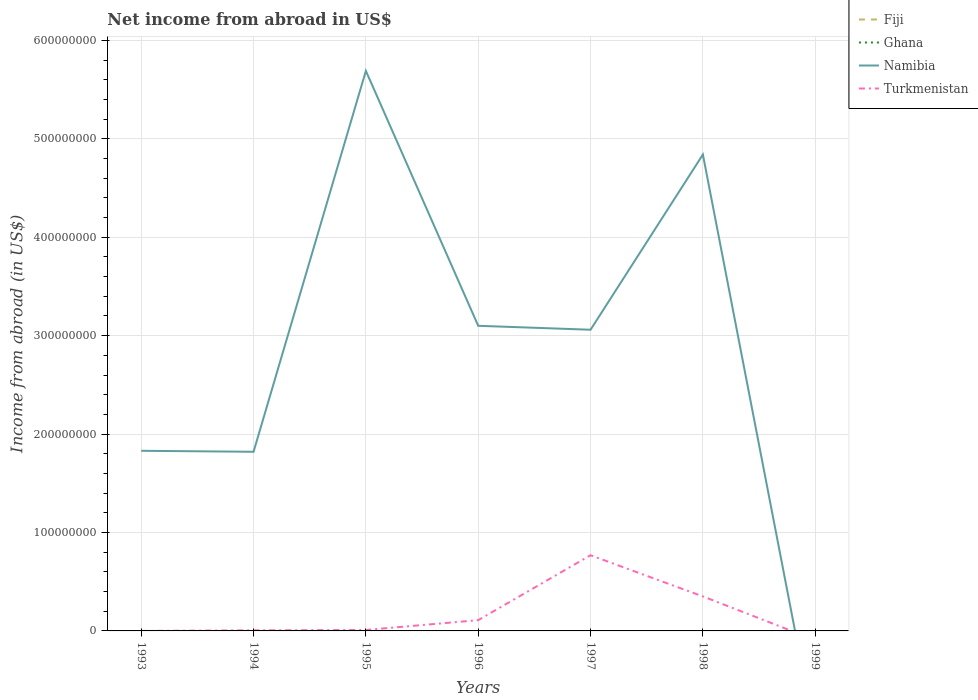How many different coloured lines are there?
Offer a terse response. 2. Does the line corresponding to Turkmenistan intersect with the line corresponding to Ghana?
Give a very brief answer. No. Is the number of lines equal to the number of legend labels?
Provide a short and direct response. No. Across all years, what is the maximum net income from abroad in Turkmenistan?
Keep it short and to the point. 0. What is the total net income from abroad in Turkmenistan in the graph?
Offer a terse response. -2.41e+07. What is the difference between the highest and the second highest net income from abroad in Turkmenistan?
Your response must be concise. 7.69e+07. Is the net income from abroad in Ghana strictly greater than the net income from abroad in Namibia over the years?
Make the answer very short. No. How many lines are there?
Your answer should be compact. 2. What is the difference between two consecutive major ticks on the Y-axis?
Your answer should be very brief. 1.00e+08. Does the graph contain any zero values?
Provide a succinct answer. Yes. Does the graph contain grids?
Ensure brevity in your answer.  Yes. Where does the legend appear in the graph?
Give a very brief answer. Top right. How many legend labels are there?
Make the answer very short. 4. What is the title of the graph?
Give a very brief answer. Net income from abroad in US$. Does "Lao PDR" appear as one of the legend labels in the graph?
Offer a very short reply. No. What is the label or title of the Y-axis?
Your answer should be very brief. Income from abroad (in US$). What is the Income from abroad (in US$) in Fiji in 1993?
Offer a terse response. 0. What is the Income from abroad (in US$) of Ghana in 1993?
Provide a short and direct response. 0. What is the Income from abroad (in US$) of Namibia in 1993?
Your response must be concise. 1.83e+08. What is the Income from abroad (in US$) in Turkmenistan in 1993?
Provide a succinct answer. 1.42e+04. What is the Income from abroad (in US$) of Namibia in 1994?
Ensure brevity in your answer.  1.82e+08. What is the Income from abroad (in US$) in Turkmenistan in 1994?
Make the answer very short. 6.22e+05. What is the Income from abroad (in US$) in Fiji in 1995?
Make the answer very short. 0. What is the Income from abroad (in US$) of Namibia in 1995?
Ensure brevity in your answer.  5.69e+08. What is the Income from abroad (in US$) in Turkmenistan in 1995?
Make the answer very short. 9.67e+05. What is the Income from abroad (in US$) of Ghana in 1996?
Give a very brief answer. 0. What is the Income from abroad (in US$) of Namibia in 1996?
Your answer should be very brief. 3.10e+08. What is the Income from abroad (in US$) of Turkmenistan in 1996?
Provide a succinct answer. 1.09e+07. What is the Income from abroad (in US$) in Fiji in 1997?
Provide a short and direct response. 0. What is the Income from abroad (in US$) of Namibia in 1997?
Provide a succinct answer. 3.06e+08. What is the Income from abroad (in US$) in Turkmenistan in 1997?
Your response must be concise. 7.69e+07. What is the Income from abroad (in US$) in Namibia in 1998?
Your response must be concise. 4.84e+08. What is the Income from abroad (in US$) of Turkmenistan in 1998?
Provide a succinct answer. 3.51e+07. What is the Income from abroad (in US$) of Fiji in 1999?
Make the answer very short. 0. Across all years, what is the maximum Income from abroad (in US$) in Namibia?
Your answer should be compact. 5.69e+08. Across all years, what is the maximum Income from abroad (in US$) of Turkmenistan?
Provide a succinct answer. 7.69e+07. Across all years, what is the minimum Income from abroad (in US$) in Namibia?
Make the answer very short. 0. What is the total Income from abroad (in US$) in Fiji in the graph?
Provide a succinct answer. 0. What is the total Income from abroad (in US$) in Ghana in the graph?
Offer a very short reply. 0. What is the total Income from abroad (in US$) in Namibia in the graph?
Your answer should be very brief. 2.03e+09. What is the total Income from abroad (in US$) in Turkmenistan in the graph?
Keep it short and to the point. 1.25e+08. What is the difference between the Income from abroad (in US$) of Turkmenistan in 1993 and that in 1994?
Your answer should be compact. -6.08e+05. What is the difference between the Income from abroad (in US$) of Namibia in 1993 and that in 1995?
Offer a terse response. -3.86e+08. What is the difference between the Income from abroad (in US$) of Turkmenistan in 1993 and that in 1995?
Offer a very short reply. -9.52e+05. What is the difference between the Income from abroad (in US$) in Namibia in 1993 and that in 1996?
Give a very brief answer. -1.27e+08. What is the difference between the Income from abroad (in US$) in Turkmenistan in 1993 and that in 1996?
Your answer should be compact. -1.09e+07. What is the difference between the Income from abroad (in US$) in Namibia in 1993 and that in 1997?
Ensure brevity in your answer.  -1.23e+08. What is the difference between the Income from abroad (in US$) of Turkmenistan in 1993 and that in 1997?
Make the answer very short. -7.69e+07. What is the difference between the Income from abroad (in US$) in Namibia in 1993 and that in 1998?
Offer a very short reply. -3.01e+08. What is the difference between the Income from abroad (in US$) in Turkmenistan in 1993 and that in 1998?
Provide a short and direct response. -3.50e+07. What is the difference between the Income from abroad (in US$) of Namibia in 1994 and that in 1995?
Your answer should be very brief. -3.87e+08. What is the difference between the Income from abroad (in US$) of Turkmenistan in 1994 and that in 1995?
Give a very brief answer. -3.44e+05. What is the difference between the Income from abroad (in US$) of Namibia in 1994 and that in 1996?
Provide a short and direct response. -1.28e+08. What is the difference between the Income from abroad (in US$) in Turkmenistan in 1994 and that in 1996?
Offer a very short reply. -1.03e+07. What is the difference between the Income from abroad (in US$) of Namibia in 1994 and that in 1997?
Offer a very short reply. -1.24e+08. What is the difference between the Income from abroad (in US$) in Turkmenistan in 1994 and that in 1997?
Your answer should be compact. -7.63e+07. What is the difference between the Income from abroad (in US$) of Namibia in 1994 and that in 1998?
Your answer should be very brief. -3.02e+08. What is the difference between the Income from abroad (in US$) of Turkmenistan in 1994 and that in 1998?
Provide a succinct answer. -3.44e+07. What is the difference between the Income from abroad (in US$) of Namibia in 1995 and that in 1996?
Make the answer very short. 2.59e+08. What is the difference between the Income from abroad (in US$) in Turkmenistan in 1995 and that in 1996?
Provide a short and direct response. -9.98e+06. What is the difference between the Income from abroad (in US$) in Namibia in 1995 and that in 1997?
Provide a succinct answer. 2.63e+08. What is the difference between the Income from abroad (in US$) of Turkmenistan in 1995 and that in 1997?
Your answer should be compact. -7.59e+07. What is the difference between the Income from abroad (in US$) of Namibia in 1995 and that in 1998?
Offer a terse response. 8.50e+07. What is the difference between the Income from abroad (in US$) of Turkmenistan in 1995 and that in 1998?
Give a very brief answer. -3.41e+07. What is the difference between the Income from abroad (in US$) of Namibia in 1996 and that in 1997?
Your answer should be very brief. 4.00e+06. What is the difference between the Income from abroad (in US$) of Turkmenistan in 1996 and that in 1997?
Give a very brief answer. -6.60e+07. What is the difference between the Income from abroad (in US$) of Namibia in 1996 and that in 1998?
Your response must be concise. -1.74e+08. What is the difference between the Income from abroad (in US$) of Turkmenistan in 1996 and that in 1998?
Provide a succinct answer. -2.41e+07. What is the difference between the Income from abroad (in US$) of Namibia in 1997 and that in 1998?
Your response must be concise. -1.78e+08. What is the difference between the Income from abroad (in US$) in Turkmenistan in 1997 and that in 1998?
Your response must be concise. 4.18e+07. What is the difference between the Income from abroad (in US$) of Namibia in 1993 and the Income from abroad (in US$) of Turkmenistan in 1994?
Offer a very short reply. 1.82e+08. What is the difference between the Income from abroad (in US$) in Namibia in 1993 and the Income from abroad (in US$) in Turkmenistan in 1995?
Give a very brief answer. 1.82e+08. What is the difference between the Income from abroad (in US$) of Namibia in 1993 and the Income from abroad (in US$) of Turkmenistan in 1996?
Your response must be concise. 1.72e+08. What is the difference between the Income from abroad (in US$) in Namibia in 1993 and the Income from abroad (in US$) in Turkmenistan in 1997?
Offer a terse response. 1.06e+08. What is the difference between the Income from abroad (in US$) in Namibia in 1993 and the Income from abroad (in US$) in Turkmenistan in 1998?
Provide a succinct answer. 1.48e+08. What is the difference between the Income from abroad (in US$) of Namibia in 1994 and the Income from abroad (in US$) of Turkmenistan in 1995?
Offer a terse response. 1.81e+08. What is the difference between the Income from abroad (in US$) of Namibia in 1994 and the Income from abroad (in US$) of Turkmenistan in 1996?
Provide a short and direct response. 1.71e+08. What is the difference between the Income from abroad (in US$) of Namibia in 1994 and the Income from abroad (in US$) of Turkmenistan in 1997?
Your answer should be compact. 1.05e+08. What is the difference between the Income from abroad (in US$) in Namibia in 1994 and the Income from abroad (in US$) in Turkmenistan in 1998?
Make the answer very short. 1.47e+08. What is the difference between the Income from abroad (in US$) of Namibia in 1995 and the Income from abroad (in US$) of Turkmenistan in 1996?
Provide a short and direct response. 5.58e+08. What is the difference between the Income from abroad (in US$) of Namibia in 1995 and the Income from abroad (in US$) of Turkmenistan in 1997?
Offer a very short reply. 4.92e+08. What is the difference between the Income from abroad (in US$) of Namibia in 1995 and the Income from abroad (in US$) of Turkmenistan in 1998?
Offer a very short reply. 5.34e+08. What is the difference between the Income from abroad (in US$) of Namibia in 1996 and the Income from abroad (in US$) of Turkmenistan in 1997?
Keep it short and to the point. 2.33e+08. What is the difference between the Income from abroad (in US$) of Namibia in 1996 and the Income from abroad (in US$) of Turkmenistan in 1998?
Offer a very short reply. 2.75e+08. What is the difference between the Income from abroad (in US$) of Namibia in 1997 and the Income from abroad (in US$) of Turkmenistan in 1998?
Make the answer very short. 2.71e+08. What is the average Income from abroad (in US$) of Ghana per year?
Provide a succinct answer. 0. What is the average Income from abroad (in US$) in Namibia per year?
Provide a short and direct response. 2.91e+08. What is the average Income from abroad (in US$) of Turkmenistan per year?
Offer a very short reply. 1.78e+07. In the year 1993, what is the difference between the Income from abroad (in US$) in Namibia and Income from abroad (in US$) in Turkmenistan?
Ensure brevity in your answer.  1.83e+08. In the year 1994, what is the difference between the Income from abroad (in US$) of Namibia and Income from abroad (in US$) of Turkmenistan?
Provide a short and direct response. 1.81e+08. In the year 1995, what is the difference between the Income from abroad (in US$) of Namibia and Income from abroad (in US$) of Turkmenistan?
Offer a terse response. 5.68e+08. In the year 1996, what is the difference between the Income from abroad (in US$) of Namibia and Income from abroad (in US$) of Turkmenistan?
Offer a very short reply. 2.99e+08. In the year 1997, what is the difference between the Income from abroad (in US$) in Namibia and Income from abroad (in US$) in Turkmenistan?
Give a very brief answer. 2.29e+08. In the year 1998, what is the difference between the Income from abroad (in US$) in Namibia and Income from abroad (in US$) in Turkmenistan?
Make the answer very short. 4.49e+08. What is the ratio of the Income from abroad (in US$) of Turkmenistan in 1993 to that in 1994?
Your response must be concise. 0.02. What is the ratio of the Income from abroad (in US$) in Namibia in 1993 to that in 1995?
Keep it short and to the point. 0.32. What is the ratio of the Income from abroad (in US$) of Turkmenistan in 1993 to that in 1995?
Provide a short and direct response. 0.01. What is the ratio of the Income from abroad (in US$) of Namibia in 1993 to that in 1996?
Provide a short and direct response. 0.59. What is the ratio of the Income from abroad (in US$) of Turkmenistan in 1993 to that in 1996?
Your answer should be very brief. 0. What is the ratio of the Income from abroad (in US$) of Namibia in 1993 to that in 1997?
Your response must be concise. 0.6. What is the ratio of the Income from abroad (in US$) of Turkmenistan in 1993 to that in 1997?
Make the answer very short. 0. What is the ratio of the Income from abroad (in US$) in Namibia in 1993 to that in 1998?
Offer a terse response. 0.38. What is the ratio of the Income from abroad (in US$) in Namibia in 1994 to that in 1995?
Provide a succinct answer. 0.32. What is the ratio of the Income from abroad (in US$) in Turkmenistan in 1994 to that in 1995?
Make the answer very short. 0.64. What is the ratio of the Income from abroad (in US$) in Namibia in 1994 to that in 1996?
Make the answer very short. 0.59. What is the ratio of the Income from abroad (in US$) of Turkmenistan in 1994 to that in 1996?
Provide a succinct answer. 0.06. What is the ratio of the Income from abroad (in US$) in Namibia in 1994 to that in 1997?
Ensure brevity in your answer.  0.59. What is the ratio of the Income from abroad (in US$) in Turkmenistan in 1994 to that in 1997?
Your response must be concise. 0.01. What is the ratio of the Income from abroad (in US$) of Namibia in 1994 to that in 1998?
Your answer should be compact. 0.38. What is the ratio of the Income from abroad (in US$) in Turkmenistan in 1994 to that in 1998?
Your answer should be very brief. 0.02. What is the ratio of the Income from abroad (in US$) in Namibia in 1995 to that in 1996?
Make the answer very short. 1.84. What is the ratio of the Income from abroad (in US$) of Turkmenistan in 1995 to that in 1996?
Keep it short and to the point. 0.09. What is the ratio of the Income from abroad (in US$) in Namibia in 1995 to that in 1997?
Keep it short and to the point. 1.86. What is the ratio of the Income from abroad (in US$) of Turkmenistan in 1995 to that in 1997?
Offer a very short reply. 0.01. What is the ratio of the Income from abroad (in US$) of Namibia in 1995 to that in 1998?
Provide a succinct answer. 1.18. What is the ratio of the Income from abroad (in US$) in Turkmenistan in 1995 to that in 1998?
Give a very brief answer. 0.03. What is the ratio of the Income from abroad (in US$) in Namibia in 1996 to that in 1997?
Offer a terse response. 1.01. What is the ratio of the Income from abroad (in US$) in Turkmenistan in 1996 to that in 1997?
Your answer should be very brief. 0.14. What is the ratio of the Income from abroad (in US$) in Namibia in 1996 to that in 1998?
Your answer should be very brief. 0.64. What is the ratio of the Income from abroad (in US$) of Turkmenistan in 1996 to that in 1998?
Ensure brevity in your answer.  0.31. What is the ratio of the Income from abroad (in US$) in Namibia in 1997 to that in 1998?
Keep it short and to the point. 0.63. What is the ratio of the Income from abroad (in US$) of Turkmenistan in 1997 to that in 1998?
Offer a terse response. 2.19. What is the difference between the highest and the second highest Income from abroad (in US$) of Namibia?
Offer a very short reply. 8.50e+07. What is the difference between the highest and the second highest Income from abroad (in US$) of Turkmenistan?
Ensure brevity in your answer.  4.18e+07. What is the difference between the highest and the lowest Income from abroad (in US$) of Namibia?
Make the answer very short. 5.69e+08. What is the difference between the highest and the lowest Income from abroad (in US$) in Turkmenistan?
Provide a short and direct response. 7.69e+07. 